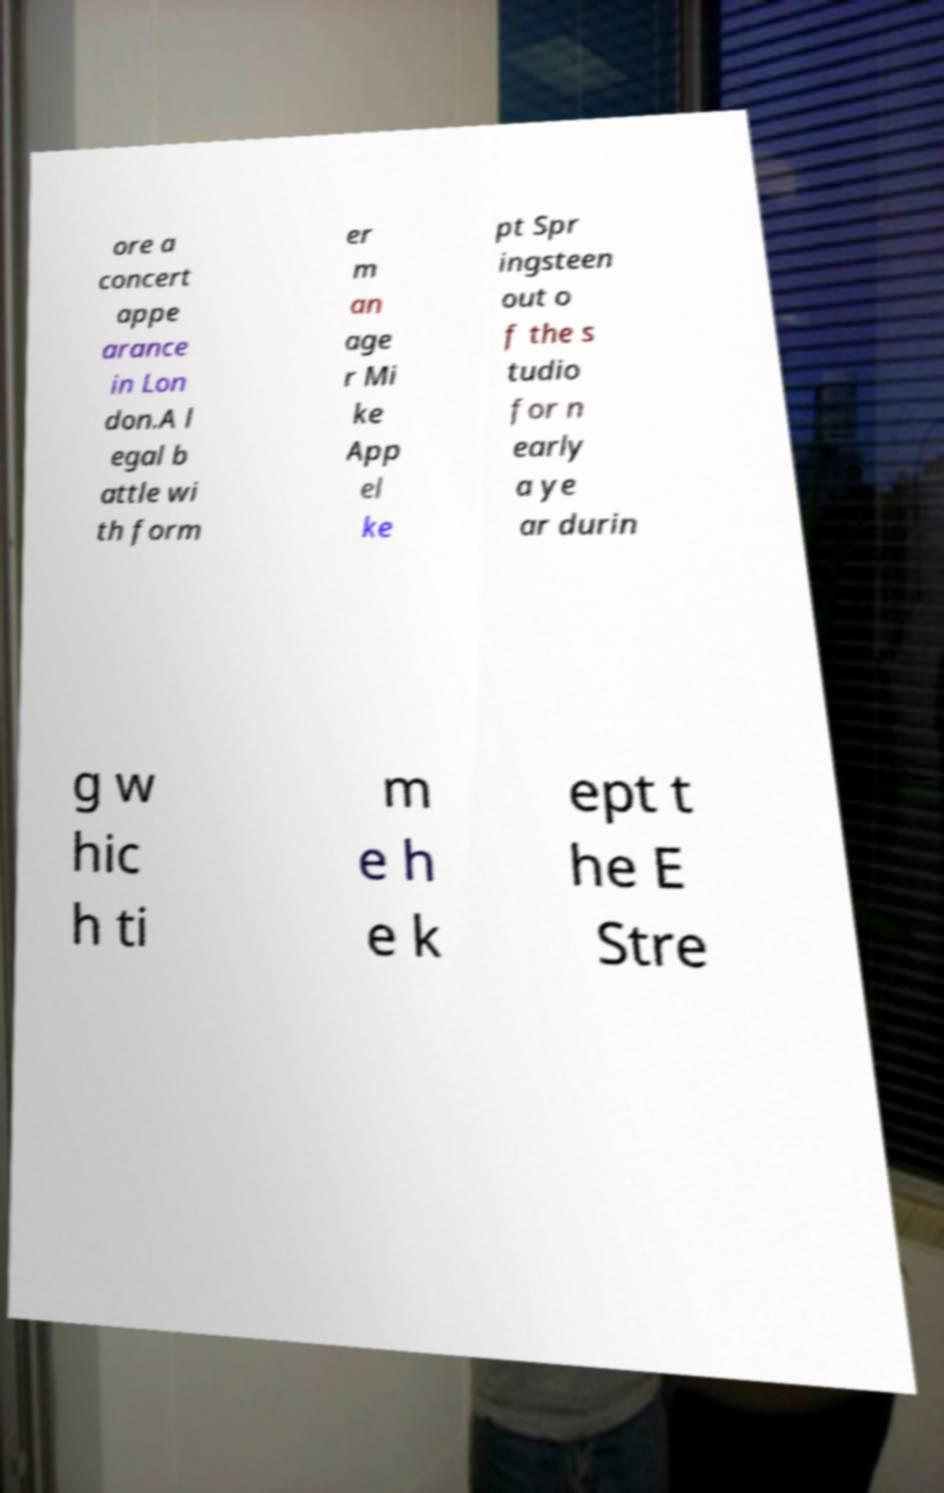Can you read and provide the text displayed in the image?This photo seems to have some interesting text. Can you extract and type it out for me? ore a concert appe arance in Lon don.A l egal b attle wi th form er m an age r Mi ke App el ke pt Spr ingsteen out o f the s tudio for n early a ye ar durin g w hic h ti m e h e k ept t he E Stre 